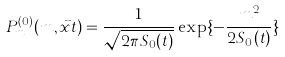<formula> <loc_0><loc_0><loc_500><loc_500>P _ { m } ^ { ( 0 ) } ( m , { \vec { x } } t ) = \frac { 1 } { \sqrt { 2 \pi S _ { 0 } ( t ) } } \exp \{ - \frac { m ^ { 2 } } { 2 S _ { 0 } ( t ) } \}</formula> 